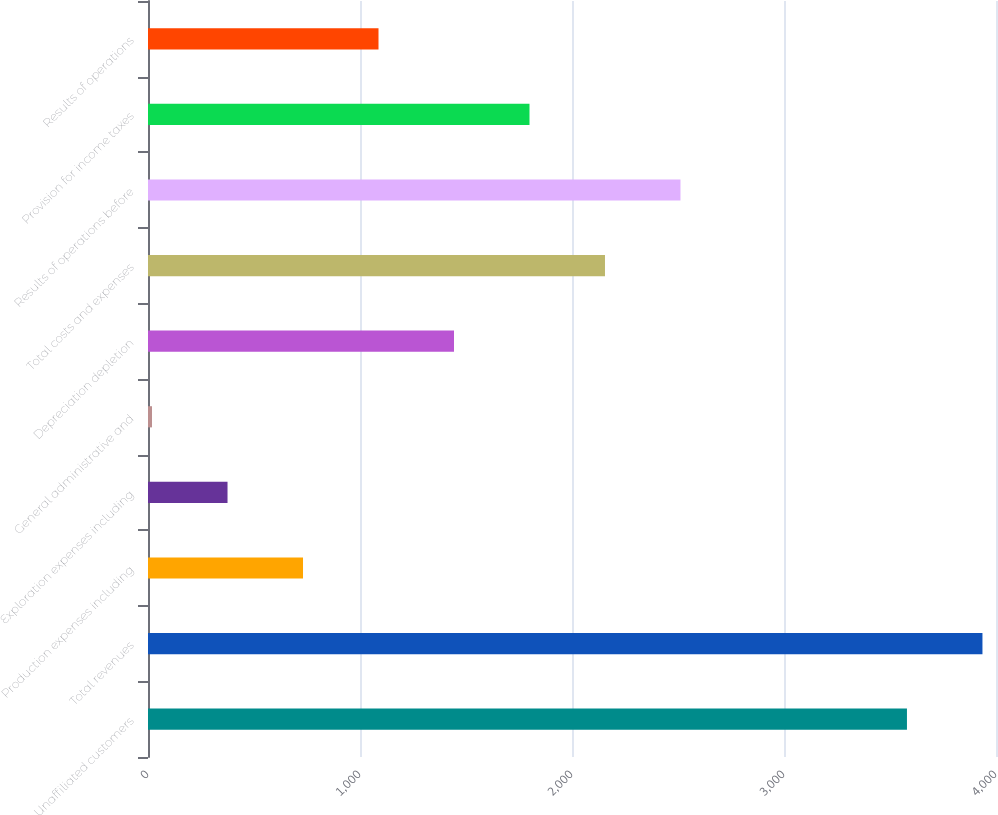<chart> <loc_0><loc_0><loc_500><loc_500><bar_chart><fcel>Unaffiliated customers<fcel>Total revenues<fcel>Production expenses including<fcel>Exploration expenses including<fcel>General administrative and<fcel>Depreciation depletion<fcel>Total costs and expenses<fcel>Results of operations before<fcel>Provision for income taxes<fcel>Results of operations<nl><fcel>3580<fcel>3936.1<fcel>731.2<fcel>375.1<fcel>19<fcel>1443.4<fcel>2155.6<fcel>2511.7<fcel>1799.5<fcel>1087.3<nl></chart> 